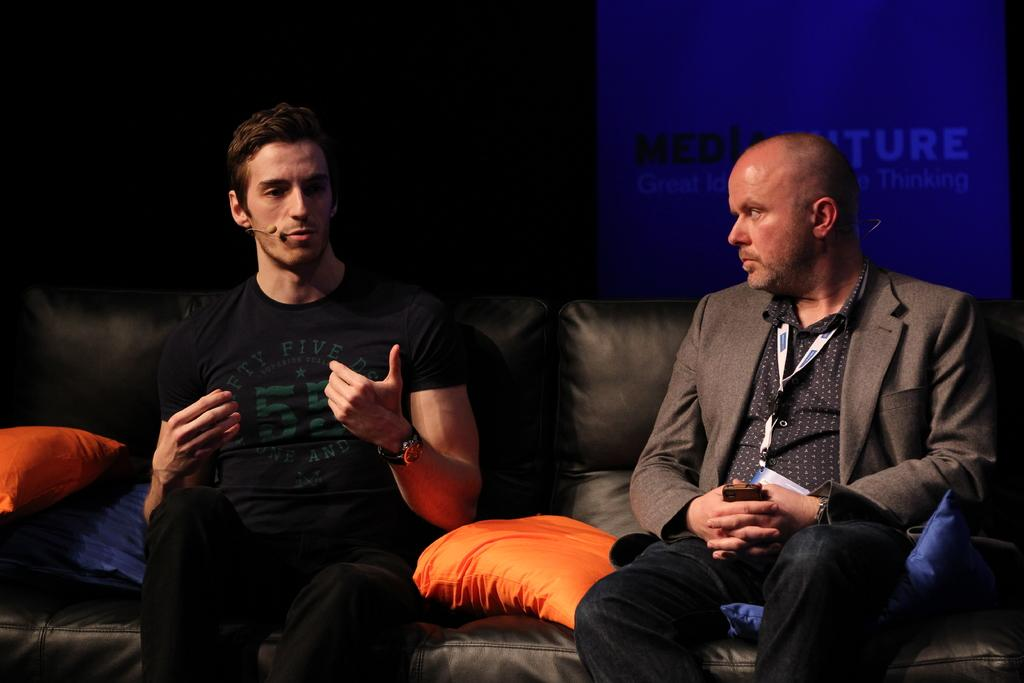How many people are in the image? There are two persons in the image. What are the persons holding in their hands? The persons are holding microphones. Where are the persons sitting? The persons are sitting on a sofa. What can be found on the sofa besides the persons? There are pillows on the sofa. What is the color of the background in the image? The background of the image is dark. What is visible in the background besides the dark color? There is a poster with text in the background. How many lizards are crawling on the sofa in the image? There are no lizards present in the image; the sofa only has pillows on it. What type of yarn is being used to create the text on the poster in the background? There is no yarn visible in the image, as the poster has text written on it, not created with yarn. 